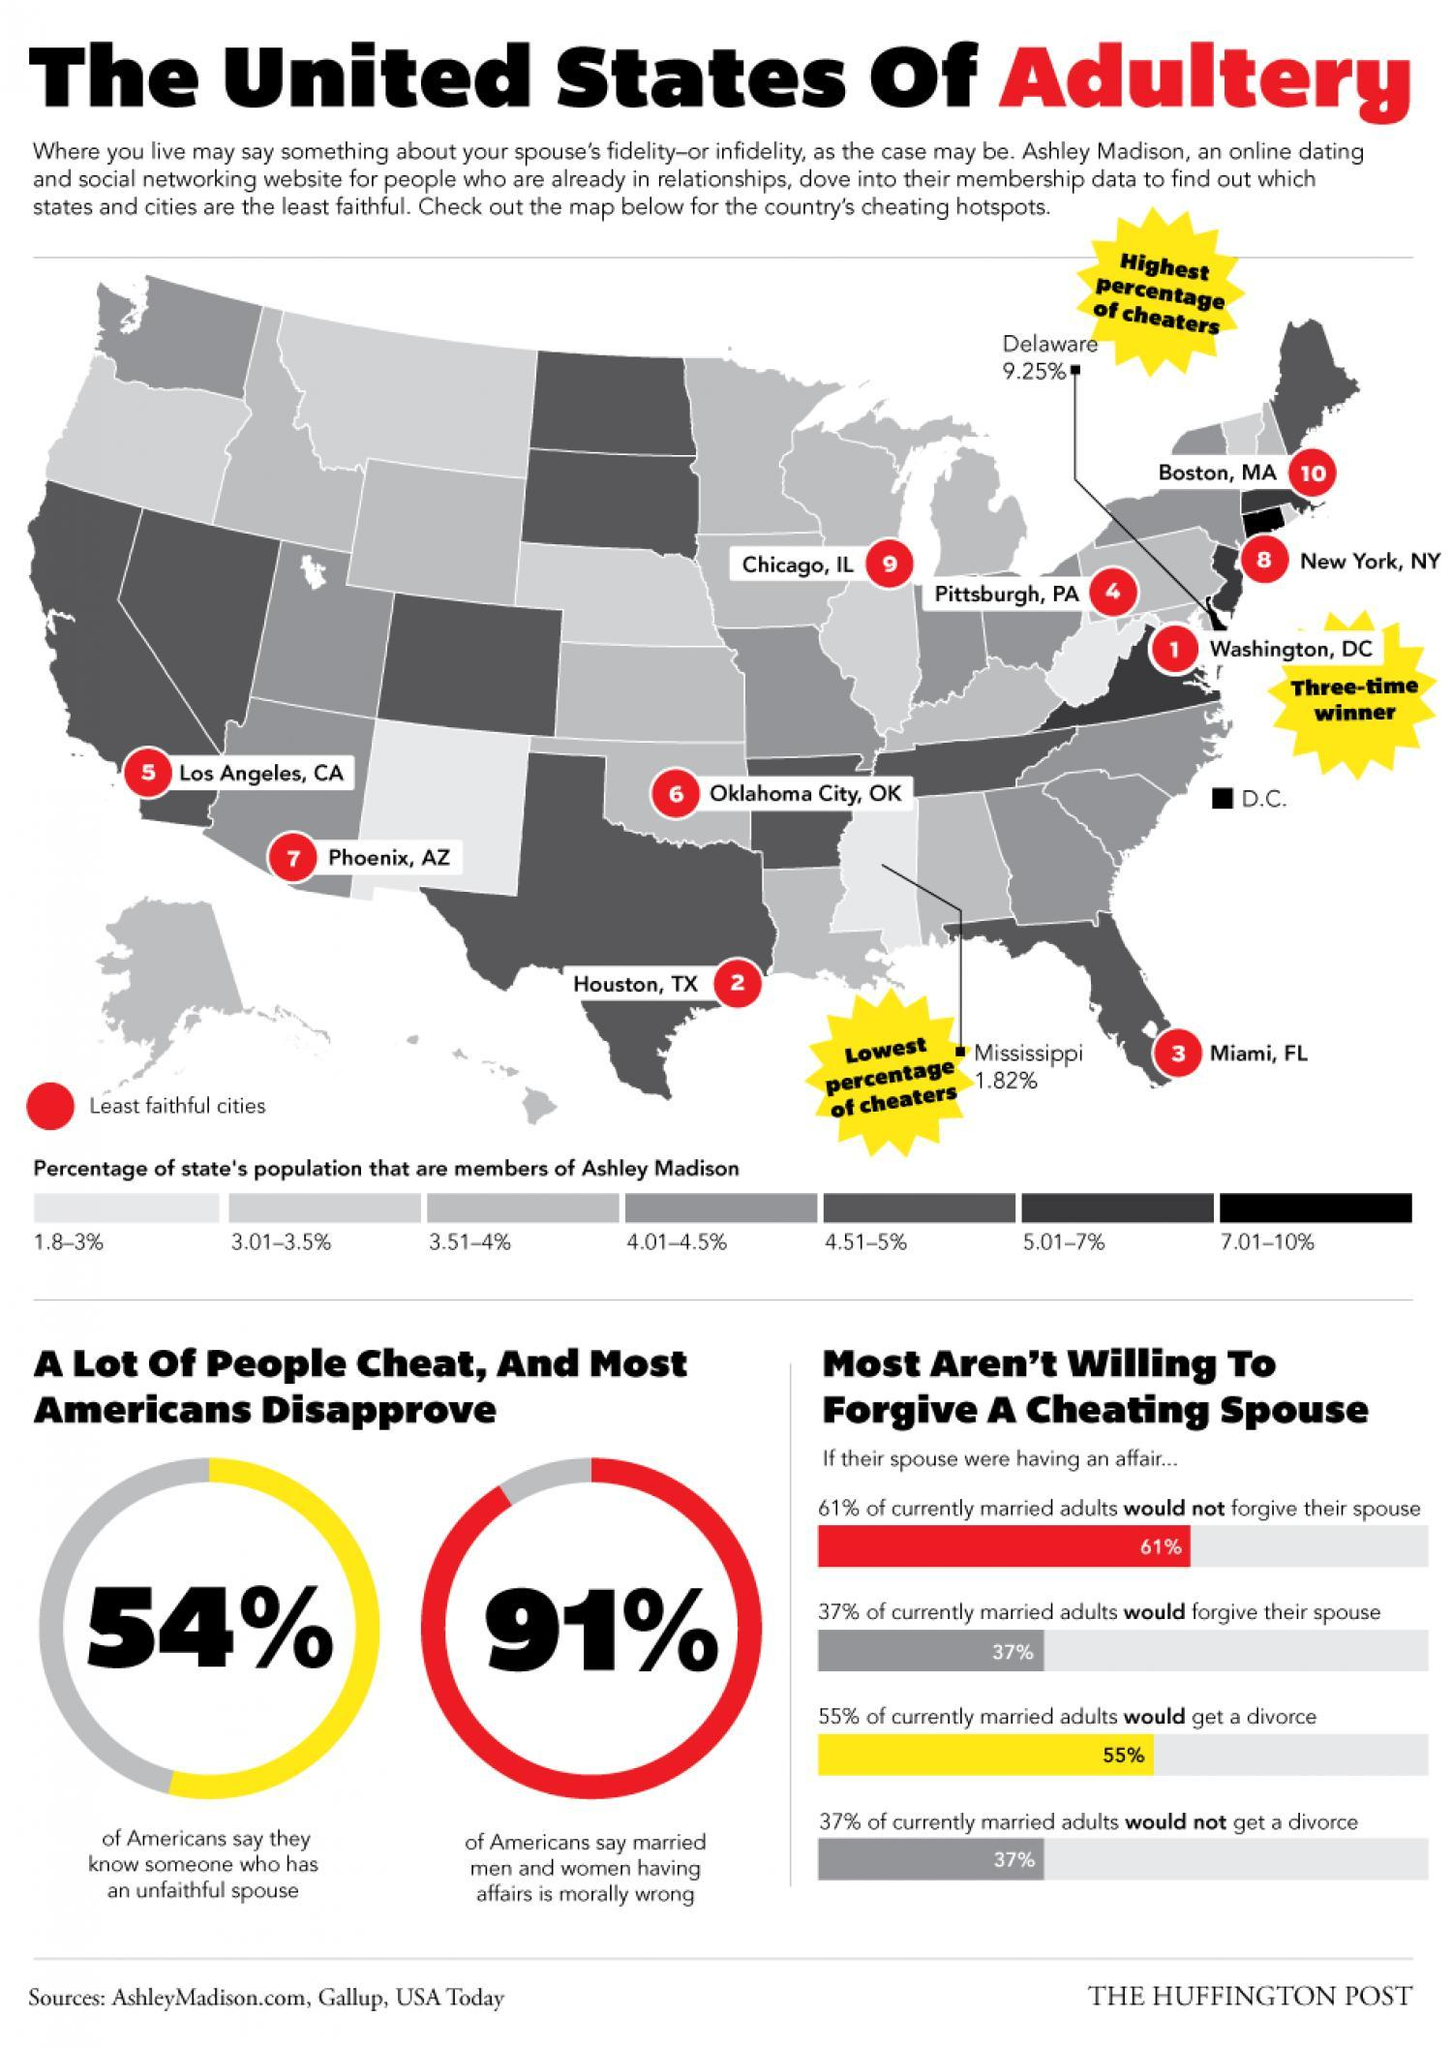What percentage of Americans do not say that married men and women having affairs is morally wrong?
Answer the question with a short phrase. 9% 